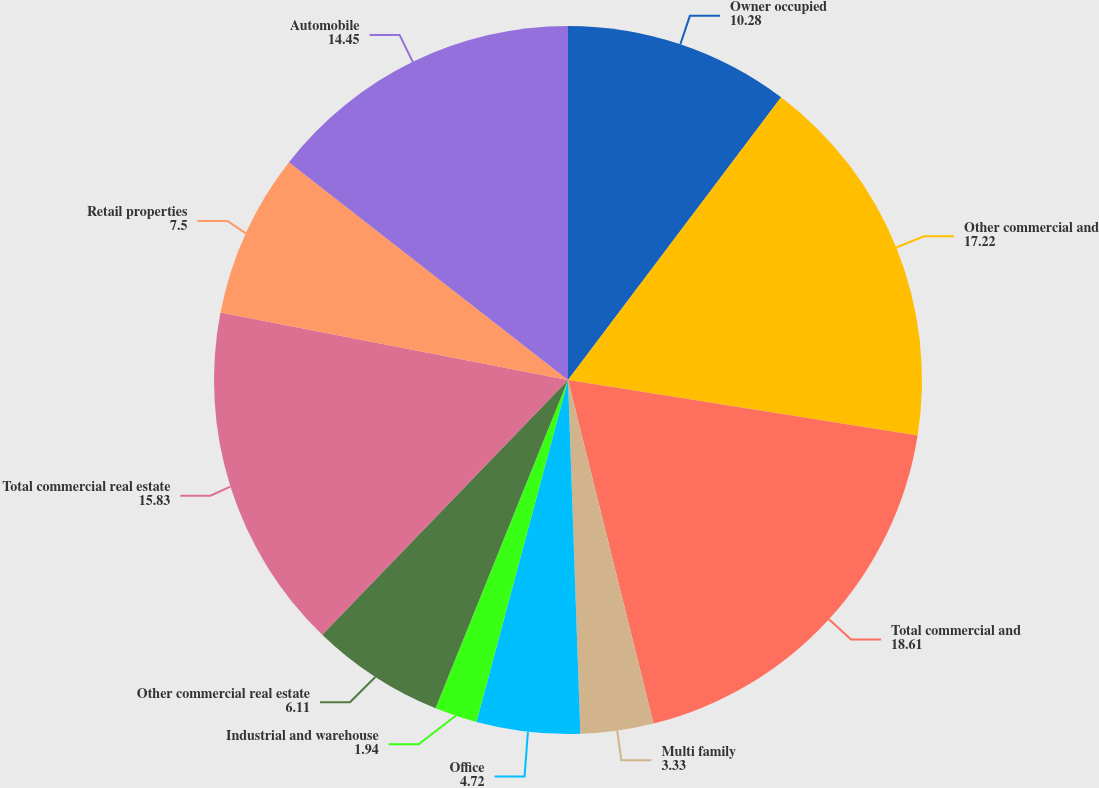<chart> <loc_0><loc_0><loc_500><loc_500><pie_chart><fcel>Owner occupied<fcel>Other commercial and<fcel>Total commercial and<fcel>Multi family<fcel>Office<fcel>Industrial and warehouse<fcel>Other commercial real estate<fcel>Total commercial real estate<fcel>Retail properties<fcel>Automobile<nl><fcel>10.28%<fcel>17.22%<fcel>18.61%<fcel>3.33%<fcel>4.72%<fcel>1.94%<fcel>6.11%<fcel>15.83%<fcel>7.5%<fcel>14.45%<nl></chart> 